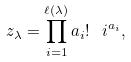Convert formula to latex. <formula><loc_0><loc_0><loc_500><loc_500>z _ { \lambda } = \prod _ { i = 1 } ^ { \ell ( \lambda ) } a _ { i } ! \ i ^ { a _ { i } } ,</formula> 